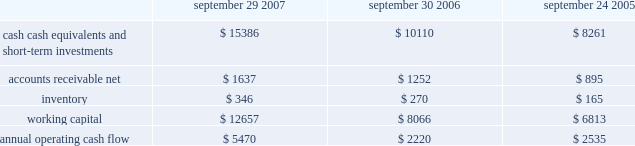No .
159 requires that unrealized gains and losses on items for which the fair value option has been elected be reported in earnings at each reporting date .
Sfas no .
159 is effective for fiscal years beginning after november 15 , 2007 and is required to be adopted by the company beginning in the first quarter of fiscal 2009 .
Although the company will continue to evaluate the application of sfas no .
159 , management does not currently believe adoption will have a material impact on the company 2019s financial condition or operating results .
In september 2006 , the fasb issued sfas no .
157 , fair value measurements , which defines fair value , provides a framework for measuring fair value , and expands the disclosures required for fair value measurements .
Sfas no .
157 applies to other accounting pronouncements that require fair value measurements ; it does not require any new fair value measurements .
Sfas no .
157 is effective for fiscal years beginning after november 15 , 2007 and is required to be adopted by the company beginning in the first quarter of fiscal 2009 .
Although the company will continue to evaluate the application of sfas no .
157 , management does not currently believe adoption will have a material impact on the company 2019s financial condition or operating results .
In june 2006 , the fasb issued fasb interpretation no .
( 2018 2018fin 2019 2019 ) 48 , accounting for uncertainty in income taxes-an interpretation of fasb statement no .
109 .
Fin 48 clarifies the accounting for uncertainty in income taxes by creating a framework for how companies should recognize , measure , present , and disclose in their financial statements uncertain tax positions that they have taken or expect to take in a tax return .
Fin 48 is effective for fiscal years beginning after december 15 , 2006 and is required to be adopted by the company beginning in the first quarter of fiscal 2008 .
Although the company will continue to evaluate the application of fin 48 , management does not currently believe adoption will have a material impact on the company 2019s financial condition or operating results .
Liquidity and capital resources the table presents selected financial information and statistics for each of the last three fiscal years ( dollars in millions ) : september 29 , september 30 , september 24 , 2007 2006 2005 .
As of september 29 , 2007 , the company had $ 15.4 billion in cash , cash equivalents , and short-term investments , an increase of $ 5.3 billion over the same balance at the end of september 30 , 2006 .
The principal components of this net increase were cash generated by operating activities of $ 5.5 billion , proceeds from the issuance of common stock under stock plans of $ 365 million and excess tax benefits from stock-based compensation of $ 377 million .
These increases were partially offset by payments for acquisitions of property , plant , and equipment of $ 735 million and payments for acquisitions of intangible assets of $ 251 million .
The company 2019s short-term investment portfolio is primarily invested in highly rated , liquid investments .
As of september 29 , 2007 and september 30 , 2006 , $ 6.5 billion and $ 4.1 billion , respectively , of the company 2019s cash , cash equivalents , and short-term investments were held by foreign subsidiaries and are generally based in u.s .
Dollar-denominated holdings .
The company believes its existing balances of cash , cash equivalents , and short-term investments will be sufficient to satisfy its working capital needs , capital expenditures , outstanding commitments , and other liquidity requirements associated with its existing operations over the next 12 months. .
What was the percentage change in inventory between 2006 and 2007? 
Computations: ((346 - 270) / 270)
Answer: 0.28148. 